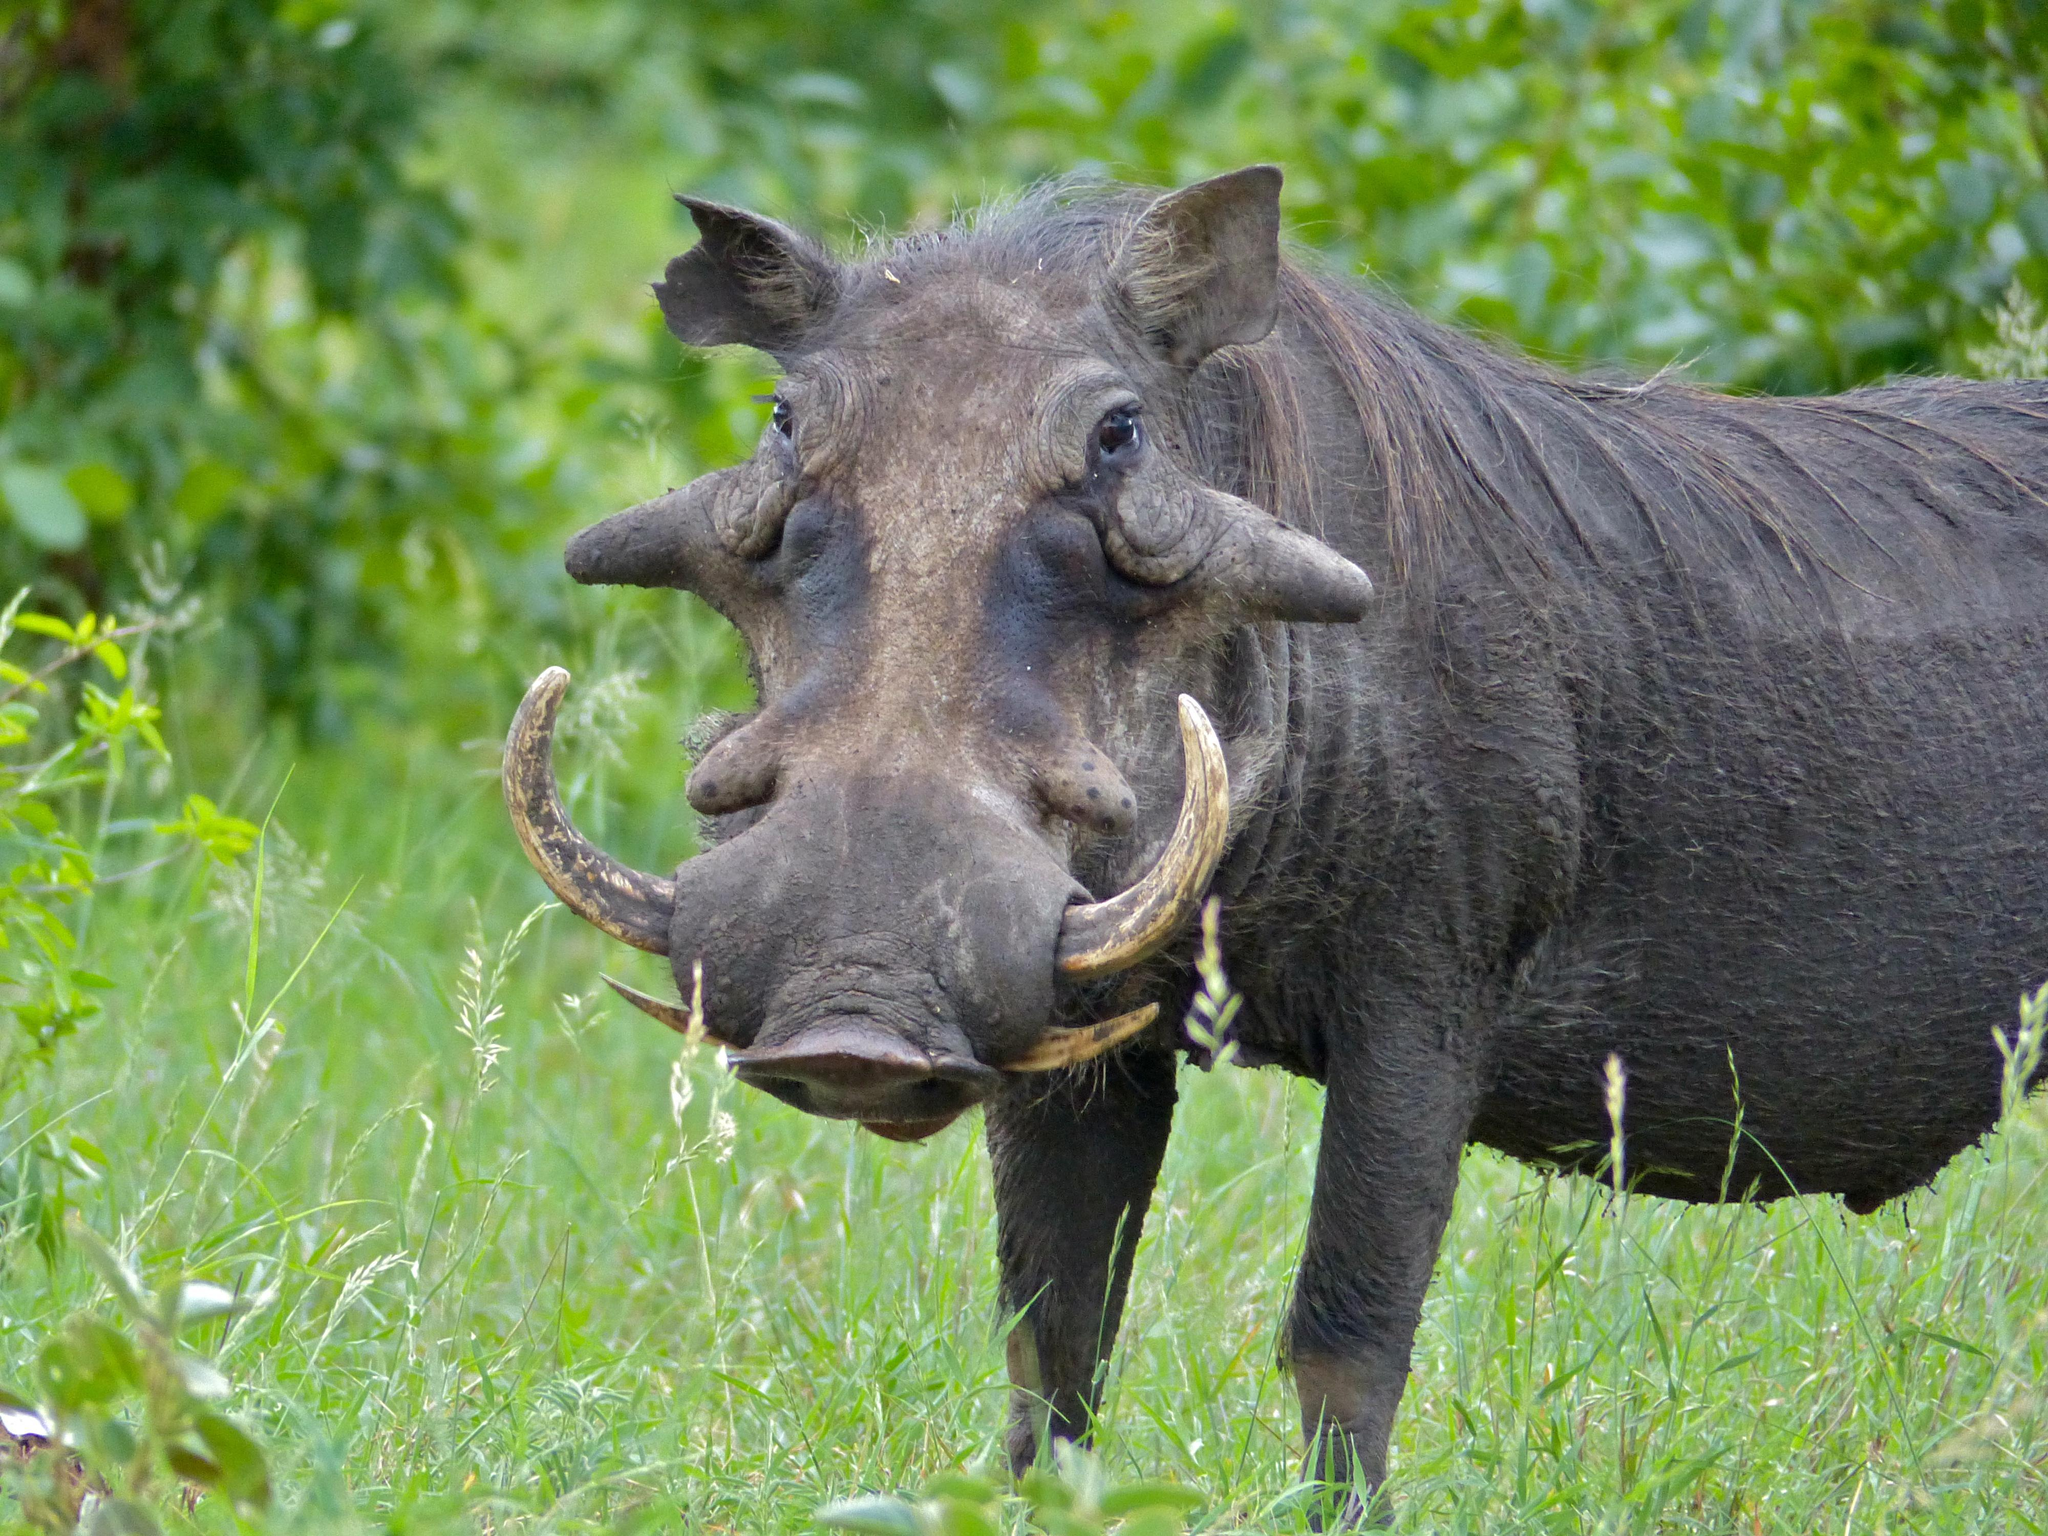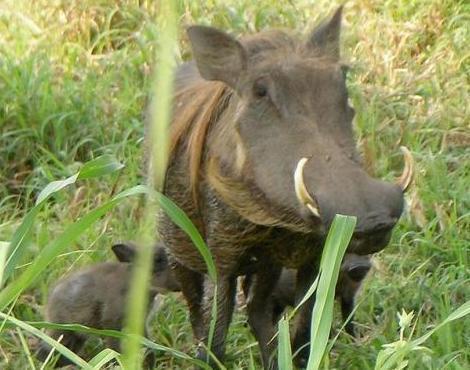The first image is the image on the left, the second image is the image on the right. Given the left and right images, does the statement "the hog on the right image is facing left." hold true? Answer yes or no. No. 